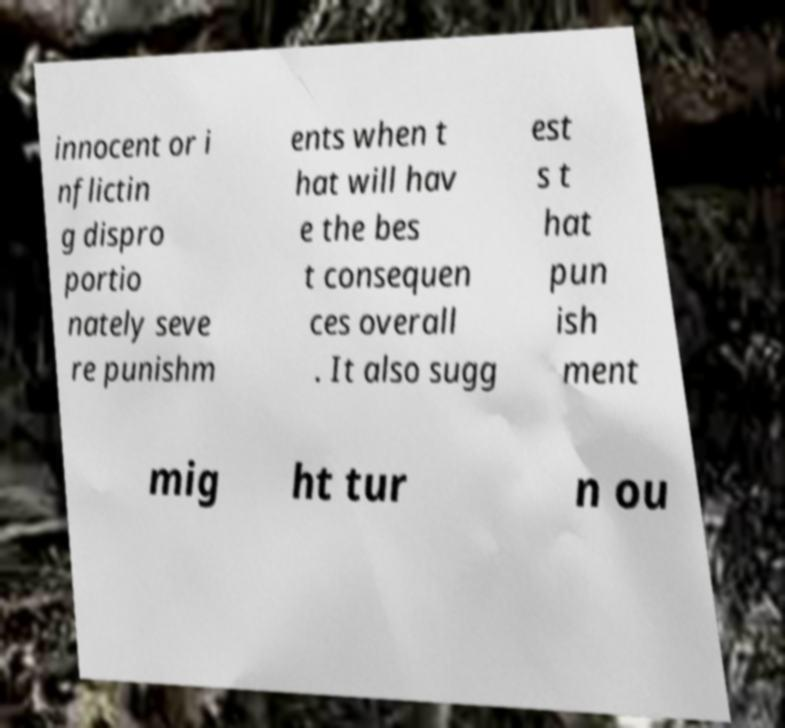Can you read and provide the text displayed in the image?This photo seems to have some interesting text. Can you extract and type it out for me? innocent or i nflictin g dispro portio nately seve re punishm ents when t hat will hav e the bes t consequen ces overall . It also sugg est s t hat pun ish ment mig ht tur n ou 